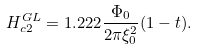<formula> <loc_0><loc_0><loc_500><loc_500>H _ { c 2 } ^ { G L } = 1 . 2 2 2 \frac { \Phi _ { 0 } } { 2 \pi \xi _ { 0 } ^ { 2 } } ( 1 - t ) .</formula> 